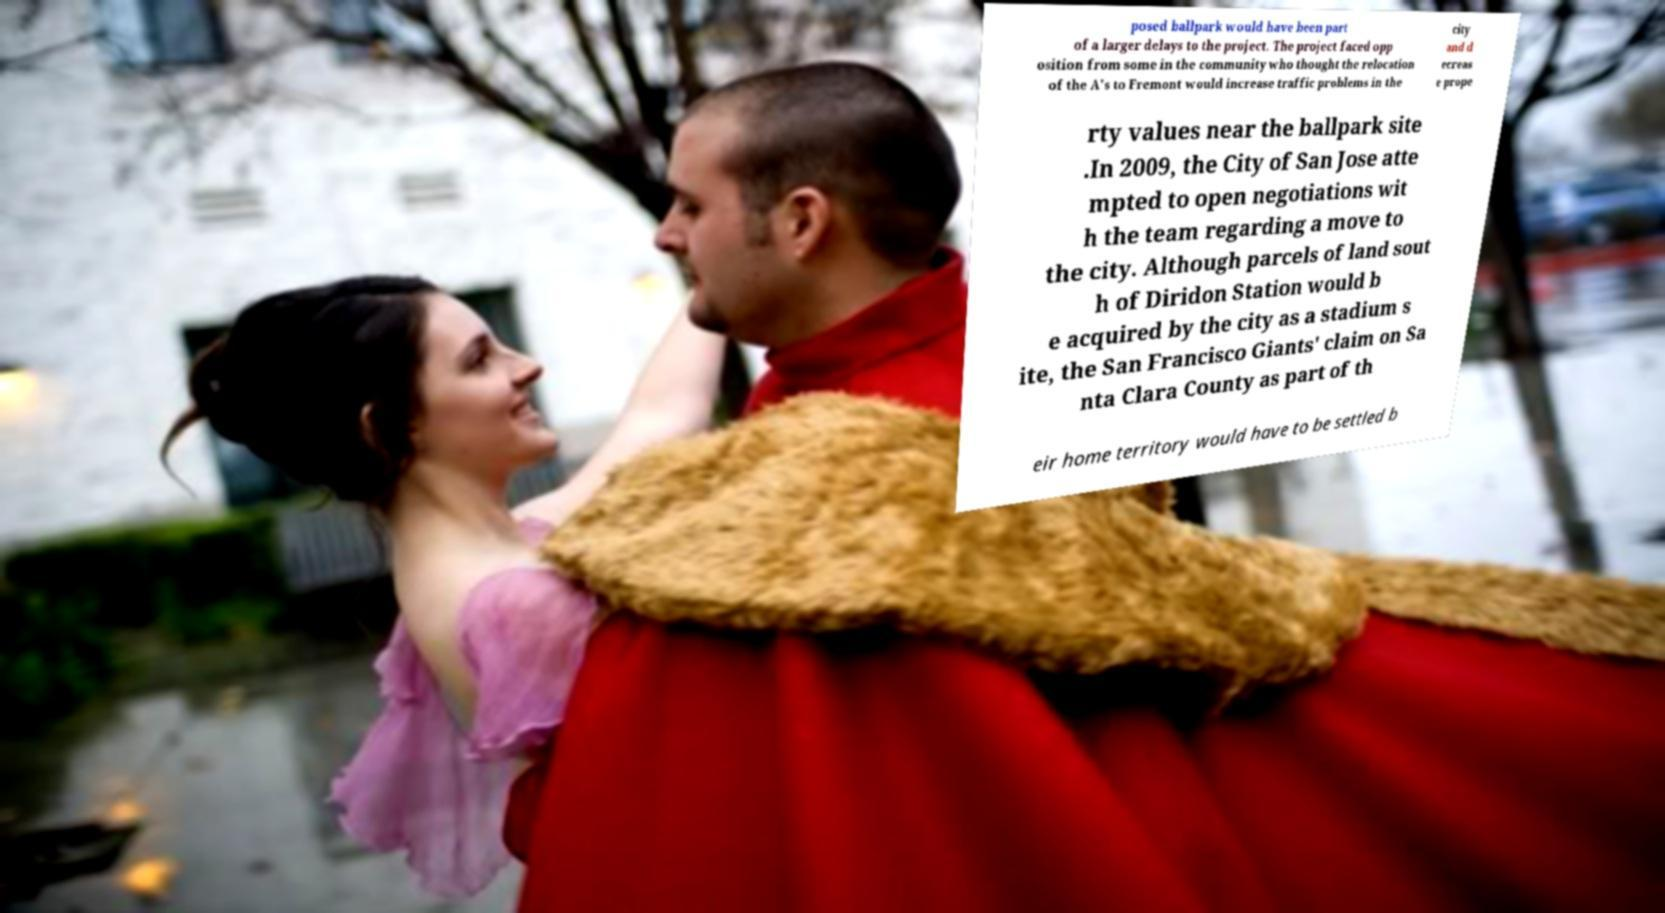Can you accurately transcribe the text from the provided image for me? posed ballpark would have been part of a larger delays to the project. The project faced opp osition from some in the community who thought the relocation of the A's to Fremont would increase traffic problems in the city and d ecreas e prope rty values near the ballpark site .In 2009, the City of San Jose atte mpted to open negotiations wit h the team regarding a move to the city. Although parcels of land sout h of Diridon Station would b e acquired by the city as a stadium s ite, the San Francisco Giants' claim on Sa nta Clara County as part of th eir home territory would have to be settled b 